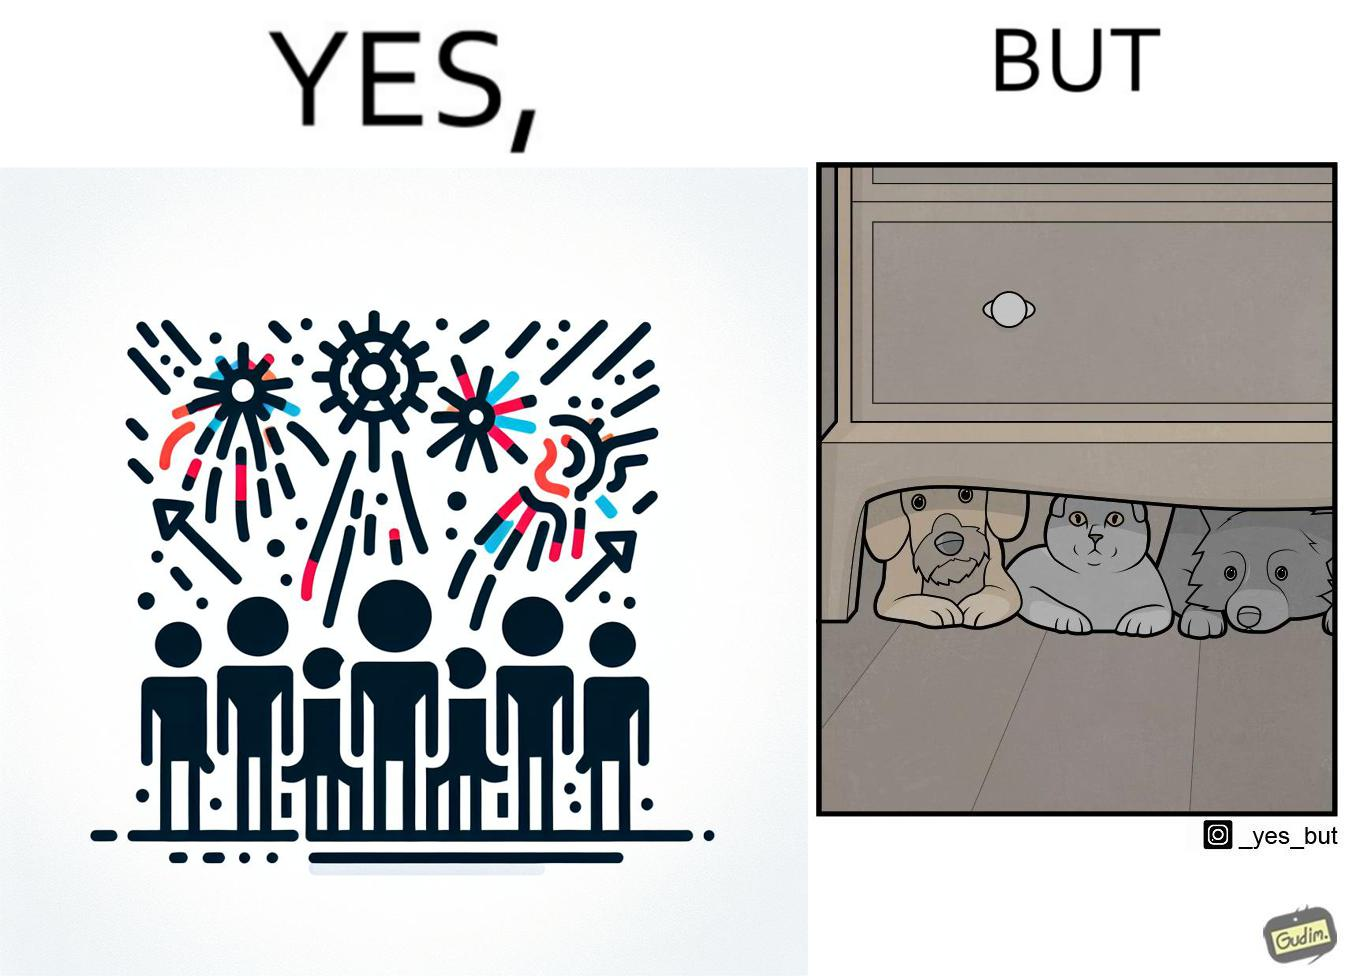Compare the left and right sides of this image. In the left part of the image: The image shows colorful firecrackers going off in the sky. In the right part of the image: The image shows two dogs and a cat hiding under furniture. 